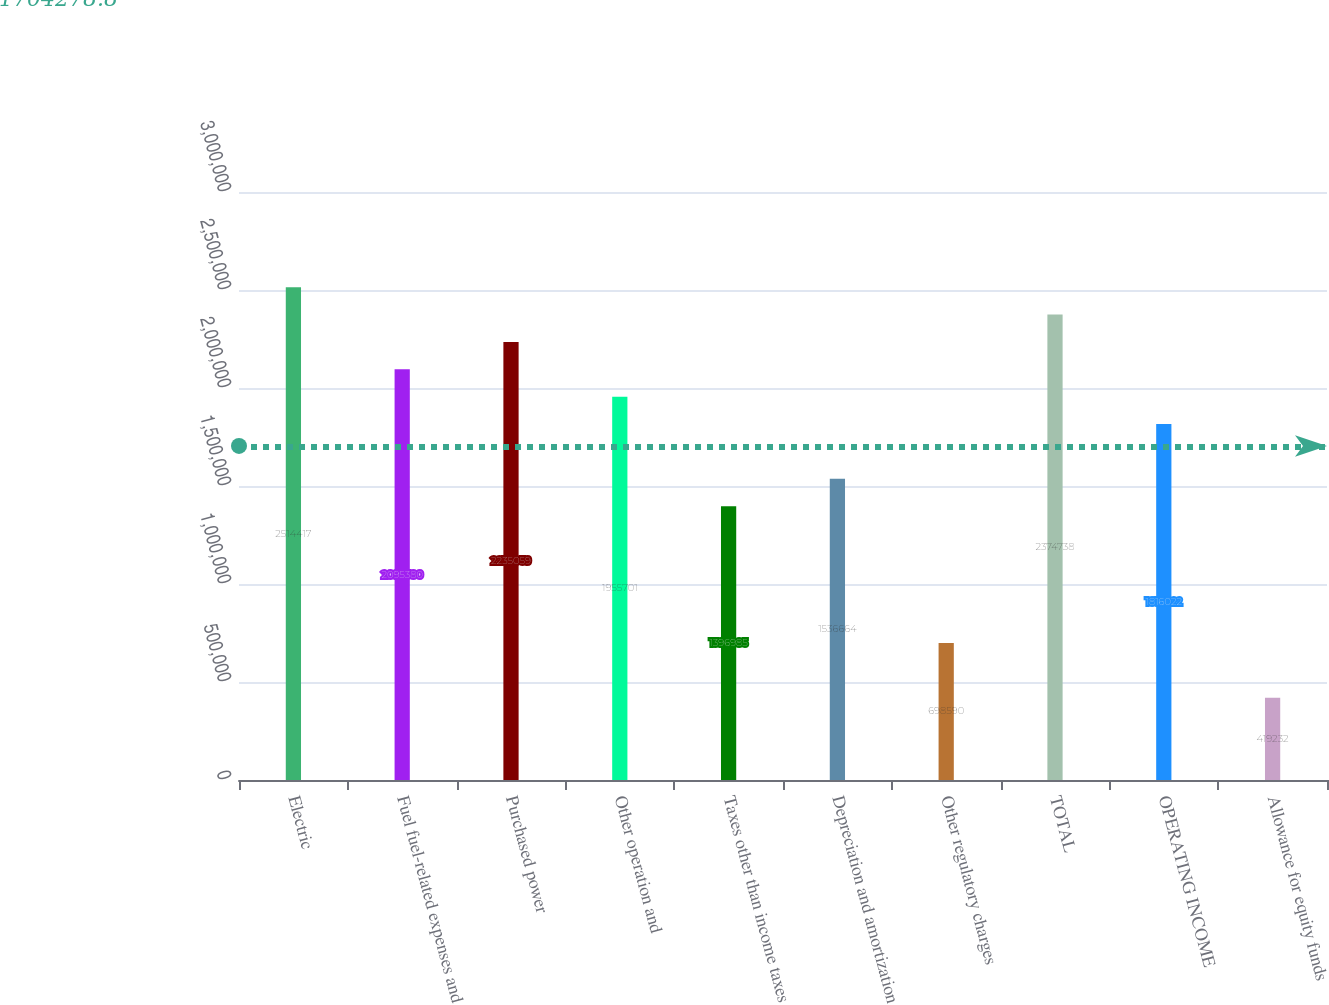Convert chart to OTSL. <chart><loc_0><loc_0><loc_500><loc_500><bar_chart><fcel>Electric<fcel>Fuel fuel-related expenses and<fcel>Purchased power<fcel>Other operation and<fcel>Taxes other than income taxes<fcel>Depreciation and amortization<fcel>Other regulatory charges<fcel>TOTAL<fcel>OPERATING INCOME<fcel>Allowance for equity funds<nl><fcel>2.51442e+06<fcel>2.09538e+06<fcel>2.23506e+06<fcel>1.9557e+06<fcel>1.39698e+06<fcel>1.53666e+06<fcel>698590<fcel>2.37474e+06<fcel>1.81602e+06<fcel>419232<nl></chart> 